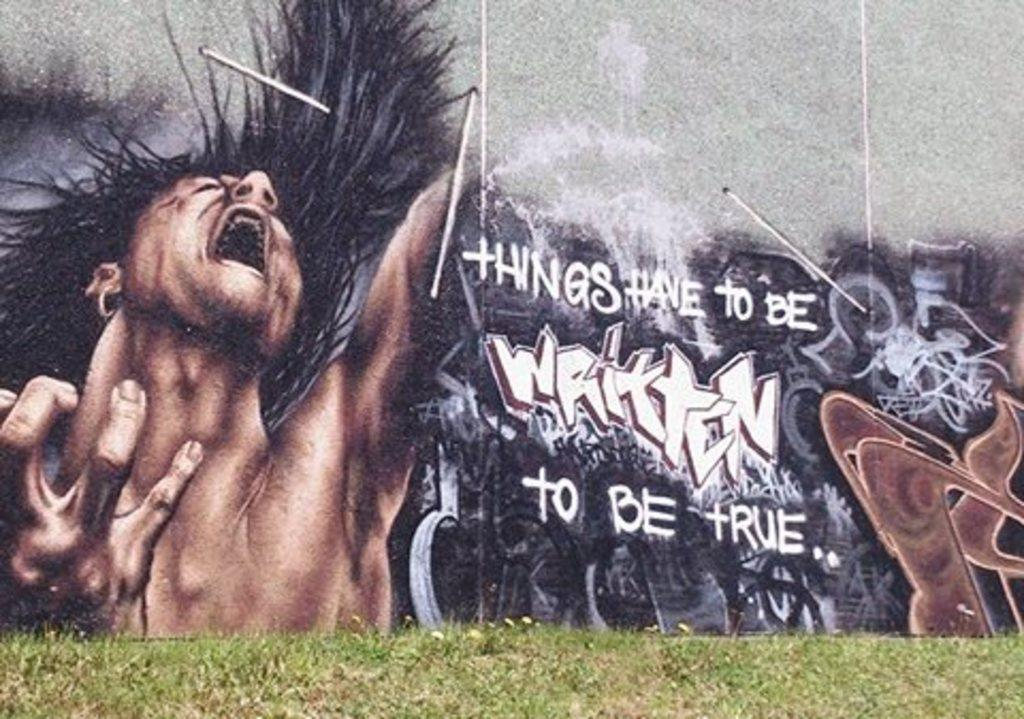<image>
Share a concise interpretation of the image provided. A wall has graffiti and the text 'things have to be written to be true'. 